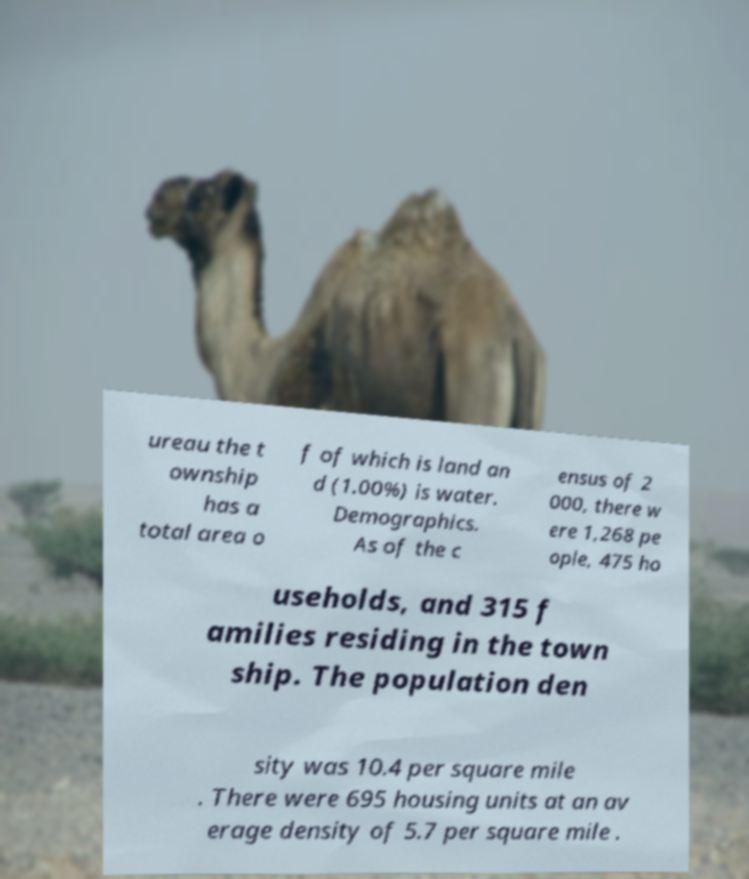Could you extract and type out the text from this image? ureau the t ownship has a total area o f of which is land an d (1.00%) is water. Demographics. As of the c ensus of 2 000, there w ere 1,268 pe ople, 475 ho useholds, and 315 f amilies residing in the town ship. The population den sity was 10.4 per square mile . There were 695 housing units at an av erage density of 5.7 per square mile . 